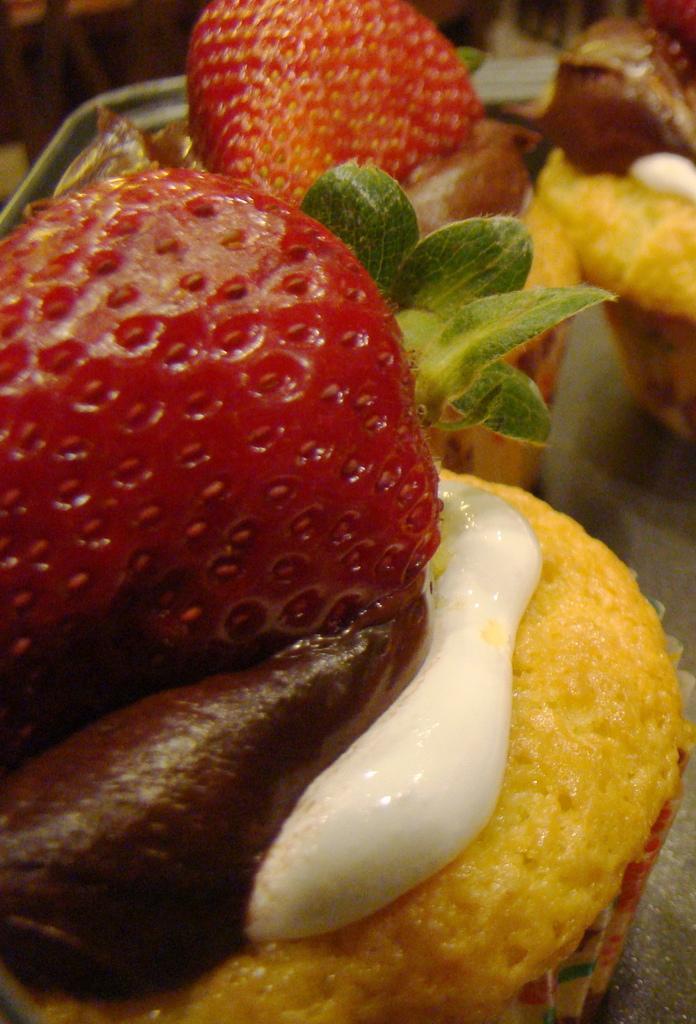Please provide a concise description of this image. This is the image of cupcakes with strawberries on it. 